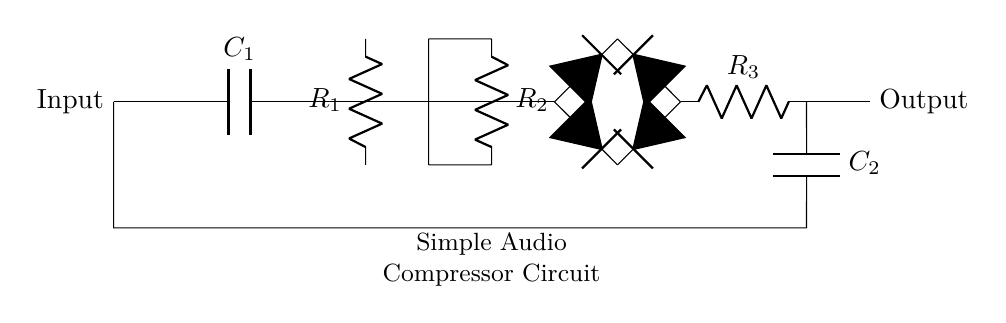What is the function of the capacitor labeled C1? The capacitor C1 is used for coupling and passing the audio signal while blocking any DC components, allowing only AC (audio) signals to pass through. This is typical in audio circuits to avoid influencing the subsequent stages with unwanted DC voltage.
Answer: Coupling What are the resistors R1 and R2 used for in this circuit? Resistors R1 and R2 are part of the gain-setting circuit in the operational amplifier configuration. They determine the amplification factor of the op-amp, which is pivotal for controlling the level of the audio signal before processing it through the compressor.
Answer: Gain control How many diodes are in the diode bridge? There are four diodes in the diode bridge. They are arranged to allow current to flow in both directions, effectively rectifying the audio signal for the compressor circuit.
Answer: Four What is the purpose of the RC network composed of R3 and C2? The RC network formed by R3 and C2 acts as a low-pass filter. It smoothes out the rectified signal by filtering out high-frequency noise, providing a cleaner signal for further processing by the compressor.
Answer: Low-pass filter What role does the operational amplifier play in this circuit? The operational amplifier amplifies the input audio signal, making it strong enough to be processed by the subsequent diodes and components. It is crucial for increasing the level of weak input signals.
Answer: Amplification 